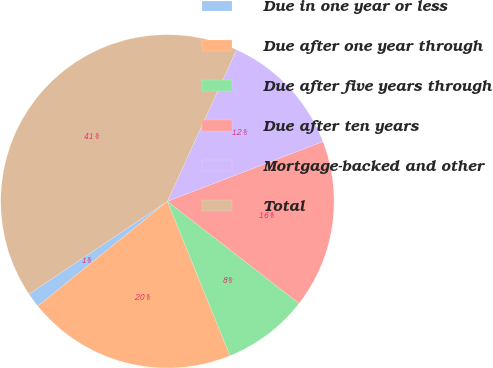Convert chart to OTSL. <chart><loc_0><loc_0><loc_500><loc_500><pie_chart><fcel>Due in one year or less<fcel>Due after one year through<fcel>Due after five years through<fcel>Due after ten years<fcel>Mortgage-backed and other<fcel>Total<nl><fcel>1.42%<fcel>20.31%<fcel>8.37%<fcel>16.33%<fcel>12.35%<fcel>41.22%<nl></chart> 